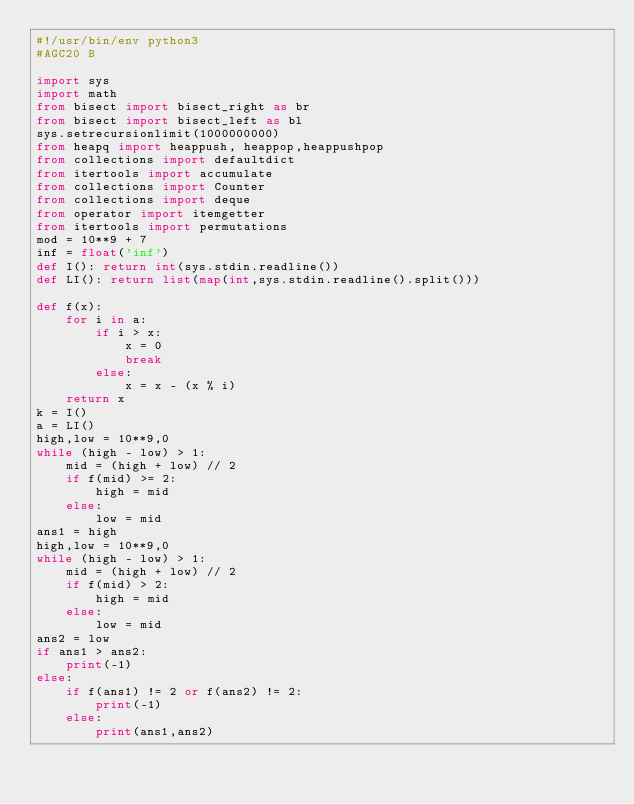Convert code to text. <code><loc_0><loc_0><loc_500><loc_500><_Python_>#!/usr/bin/env python3
#AGC20 B

import sys
import math
from bisect import bisect_right as br
from bisect import bisect_left as bl
sys.setrecursionlimit(1000000000)
from heapq import heappush, heappop,heappushpop
from collections import defaultdict
from itertools import accumulate
from collections import Counter
from collections import deque
from operator import itemgetter
from itertools import permutations
mod = 10**9 + 7
inf = float('inf')
def I(): return int(sys.stdin.readline())
def LI(): return list(map(int,sys.stdin.readline().split()))

def f(x):
    for i in a:
        if i > x:
            x = 0
            break
        else:
            x = x - (x % i)
    return x
k = I()
a = LI()
high,low = 10**9,0
while (high - low) > 1:
    mid = (high + low) // 2 
    if f(mid) >= 2:
        high = mid
    else:
        low = mid
ans1 = high
high,low = 10**9,0
while (high - low) > 1:
    mid = (high + low) // 2
    if f(mid) > 2:
        high = mid
    else:
        low = mid
ans2 = low
if ans1 > ans2:
    print(-1)
else:
    if f(ans1) != 2 or f(ans2) != 2:
        print(-1)
    else:
        print(ans1,ans2)
</code> 